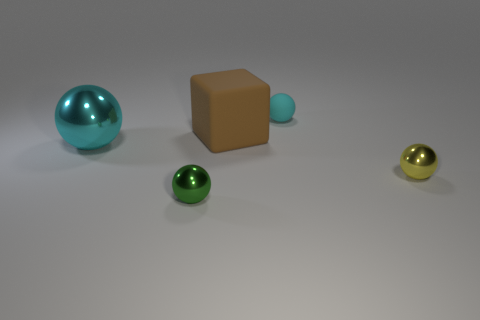There is a large shiny object; is it the same color as the small metal ball left of the tiny cyan rubber object?
Your response must be concise. No. Are there any other things that have the same size as the brown matte block?
Offer a terse response. Yes. There is a object that is left of the brown matte cube and behind the tiny green metallic ball; what size is it?
Your answer should be compact. Large. There is a small green object that is made of the same material as the big cyan ball; what is its shape?
Ensure brevity in your answer.  Sphere. Is the cube made of the same material as the small sphere on the left side of the tiny rubber ball?
Your answer should be very brief. No. Is there a cyan metal ball on the right side of the tiny ball behind the big metallic thing?
Offer a terse response. No. There is a green object that is the same shape as the yellow metal thing; what material is it?
Your response must be concise. Metal. What number of small balls are in front of the cyan thing that is behind the big cyan shiny thing?
Your response must be concise. 2. Are there any other things of the same color as the block?
Provide a short and direct response. No. How many objects are large brown rubber things or small things that are behind the green thing?
Give a very brief answer. 3. 